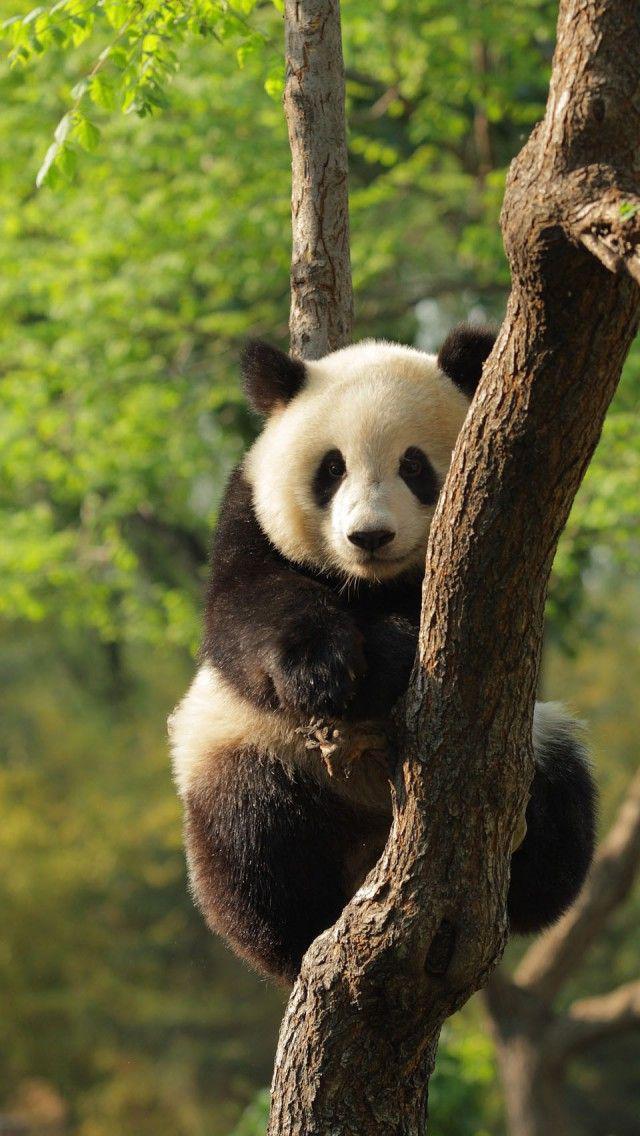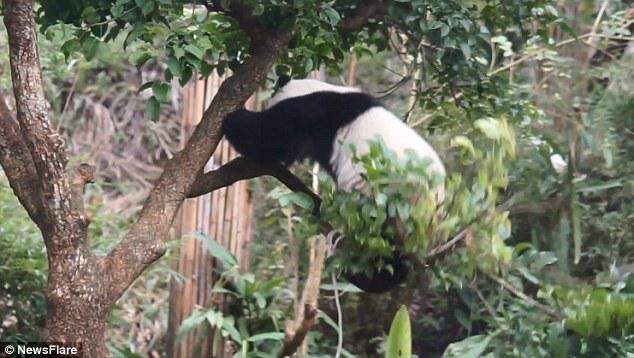The first image is the image on the left, the second image is the image on the right. Given the left and right images, does the statement "A total of two pandas are off the ground and hanging to tree limbs." hold true? Answer yes or no. Yes. 